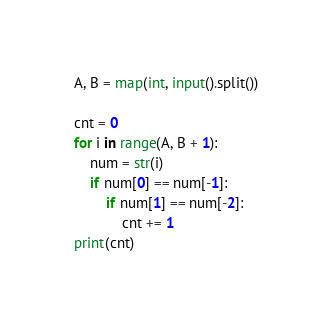<code> <loc_0><loc_0><loc_500><loc_500><_Python_>A, B = map(int, input().split())

cnt = 0
for i in range(A, B + 1):
    num = str(i)
    if num[0] == num[-1]:
        if num[1] == num[-2]:
            cnt += 1
print(cnt)</code> 